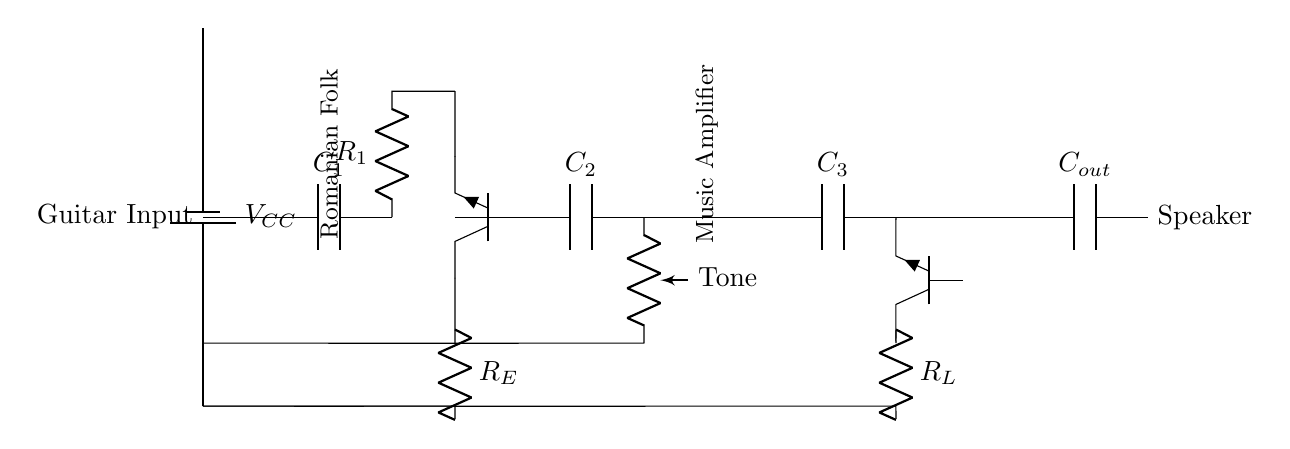What is the input component of the circuit? The input component, labeled as "Guitar Input," connects to the capacitor C1, which acts as a coupling device.
Answer: Guitar Input What are the two transistors in the circuit? The circuit contains two NPN transistors, labeled as Q1 and Q2, which serve as amplifying elements in the pre-amp and power amp stages, respectively.
Answer: Q1 and Q2 What is the purpose of capacitor C3? Capacitor C3 is placed in the power amp stage to couple the amplified signal to the speaker, blocking any DC while permitting AC signals to pass through.
Answer: Coupling What is the value of the power supply voltage? The schematic indicates a battery labeled VCC, although it does not specify an exact voltage value. However, it is typical for such amplifiers to use a voltage like 9V or 12V.
Answer: Not specified How many resistors are present in the circuit? There are two resistors, R1 and RL, included in the circuit layout. R1 is part of the pre-amp stage, and RL is used in the power amp stage.
Answer: Two What component is used for tone control? A potentiometer, labeled "Tone," is incorporated in the circuit before the power amp stage to allow adjustment of sound frequency response.
Answer: Potentiometer What is the output device of this amplifier circuit? The output device in this amplifier circuit is the "Speaker," which converts the electrical signals into audible sound.
Answer: Speaker 